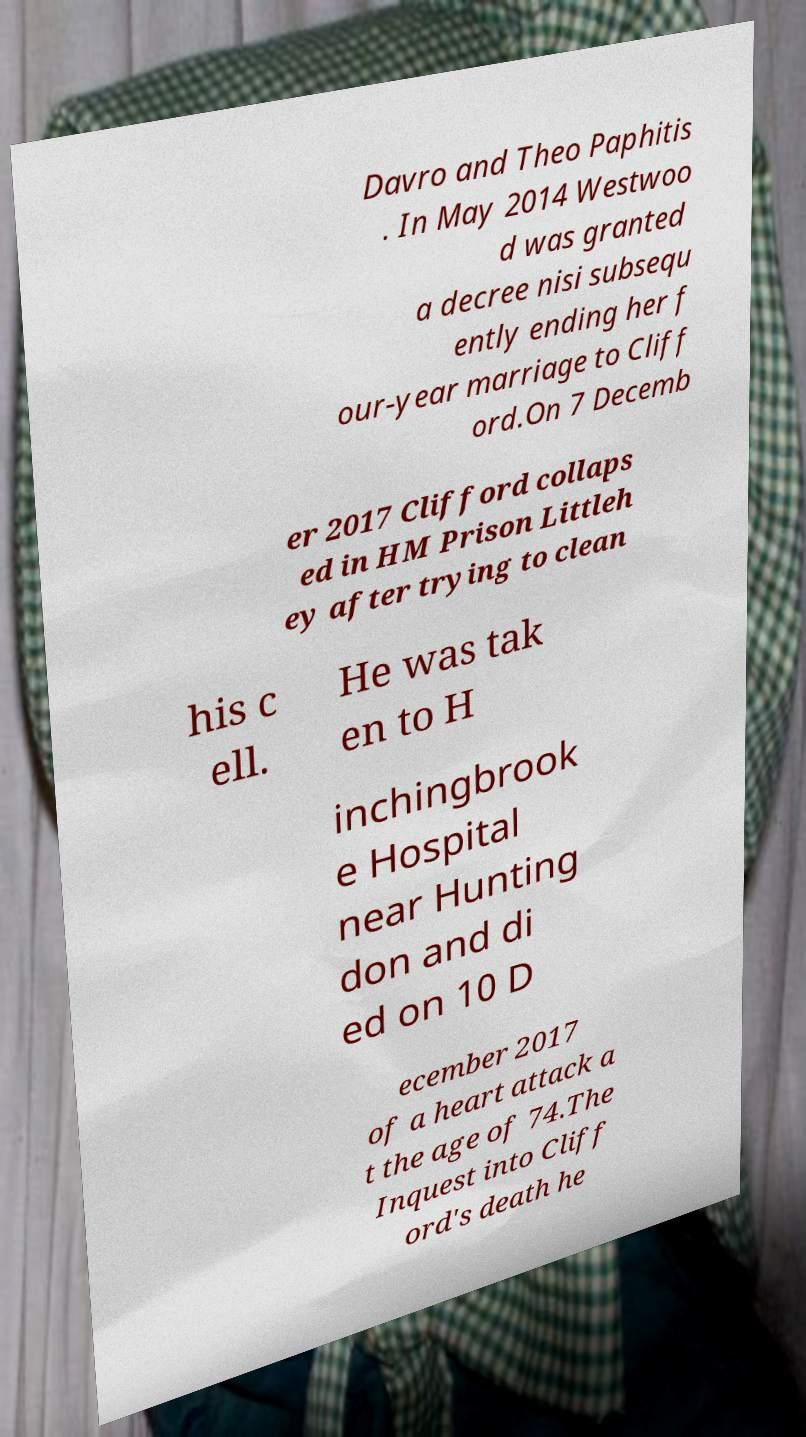For documentation purposes, I need the text within this image transcribed. Could you provide that? Davro and Theo Paphitis . In May 2014 Westwoo d was granted a decree nisi subsequ ently ending her f our-year marriage to Cliff ord.On 7 Decemb er 2017 Clifford collaps ed in HM Prison Littleh ey after trying to clean his c ell. He was tak en to H inchingbrook e Hospital near Hunting don and di ed on 10 D ecember 2017 of a heart attack a t the age of 74.The Inquest into Cliff ord's death he 